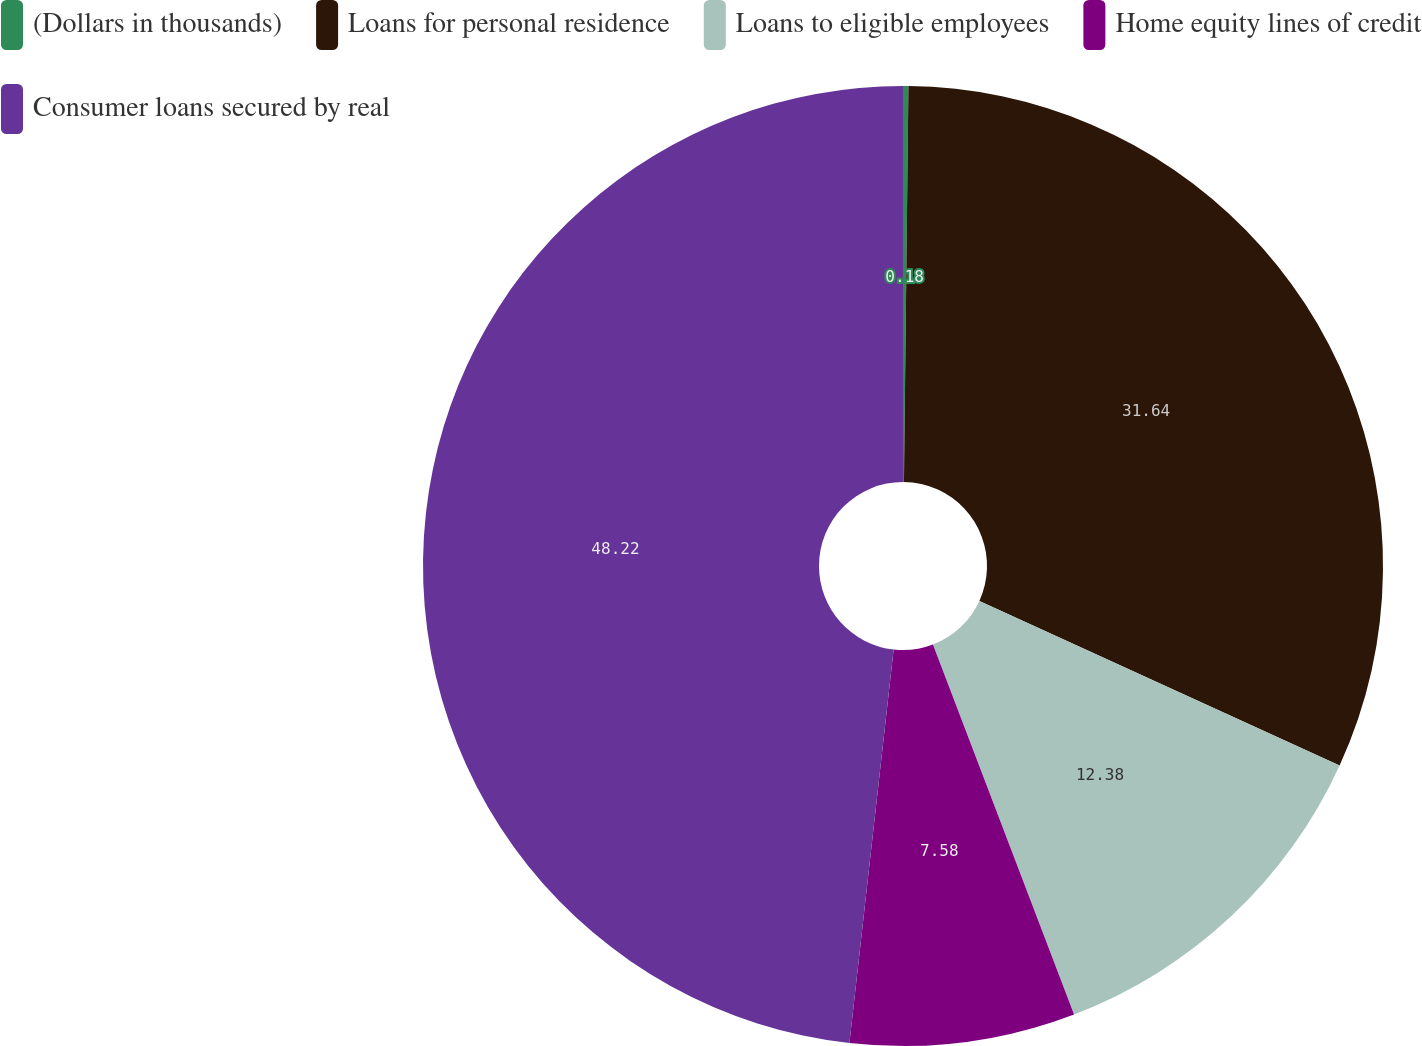Convert chart to OTSL. <chart><loc_0><loc_0><loc_500><loc_500><pie_chart><fcel>(Dollars in thousands)<fcel>Loans for personal residence<fcel>Loans to eligible employees<fcel>Home equity lines of credit<fcel>Consumer loans secured by real<nl><fcel>0.18%<fcel>31.64%<fcel>12.38%<fcel>7.58%<fcel>48.22%<nl></chart> 